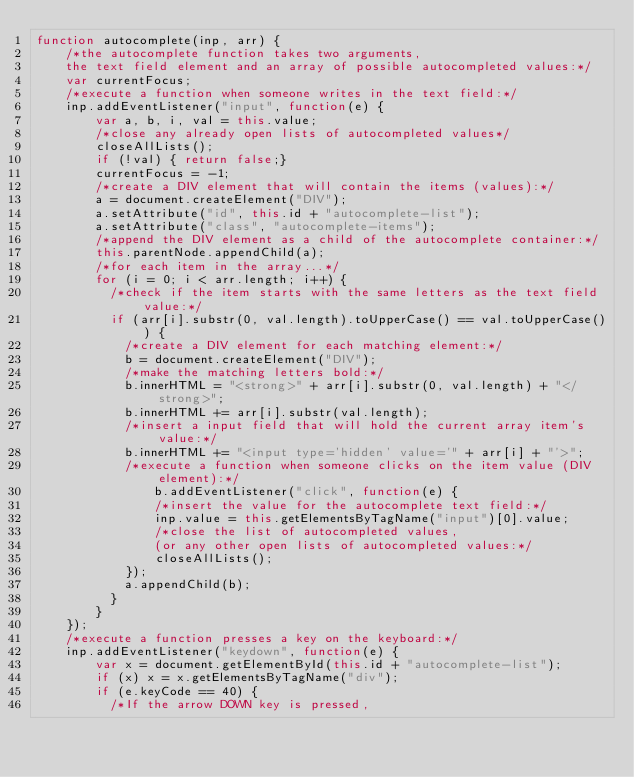<code> <loc_0><loc_0><loc_500><loc_500><_JavaScript_>function autocomplete(inp, arr) {
    /*the autocomplete function takes two arguments,
    the text field element and an array of possible autocompleted values:*/
    var currentFocus;
    /*execute a function when someone writes in the text field:*/
    inp.addEventListener("input", function(e) {
        var a, b, i, val = this.value;
        /*close any already open lists of autocompleted values*/
        closeAllLists();
        if (!val) { return false;}
        currentFocus = -1;
        /*create a DIV element that will contain the items (values):*/
        a = document.createElement("DIV");
        a.setAttribute("id", this.id + "autocomplete-list");
        a.setAttribute("class", "autocomplete-items");
        /*append the DIV element as a child of the autocomplete container:*/
        this.parentNode.appendChild(a);
        /*for each item in the array...*/
        for (i = 0; i < arr.length; i++) {
          /*check if the item starts with the same letters as the text field value:*/
          if (arr[i].substr(0, val.length).toUpperCase() == val.toUpperCase()) {
            /*create a DIV element for each matching element:*/
            b = document.createElement("DIV");
            /*make the matching letters bold:*/
            b.innerHTML = "<strong>" + arr[i].substr(0, val.length) + "</strong>";
            b.innerHTML += arr[i].substr(val.length);
            /*insert a input field that will hold the current array item's value:*/
            b.innerHTML += "<input type='hidden' value='" + arr[i] + "'>";
            /*execute a function when someone clicks on the item value (DIV element):*/
                b.addEventListener("click", function(e) {
                /*insert the value for the autocomplete text field:*/
                inp.value = this.getElementsByTagName("input")[0].value;
                /*close the list of autocompleted values,
                (or any other open lists of autocompleted values:*/
                closeAllLists();
            });
            a.appendChild(b);
          }
        }
    });
    /*execute a function presses a key on the keyboard:*/
    inp.addEventListener("keydown", function(e) {
        var x = document.getElementById(this.id + "autocomplete-list");
        if (x) x = x.getElementsByTagName("div");
        if (e.keyCode == 40) {
          /*If the arrow DOWN key is pressed,</code> 